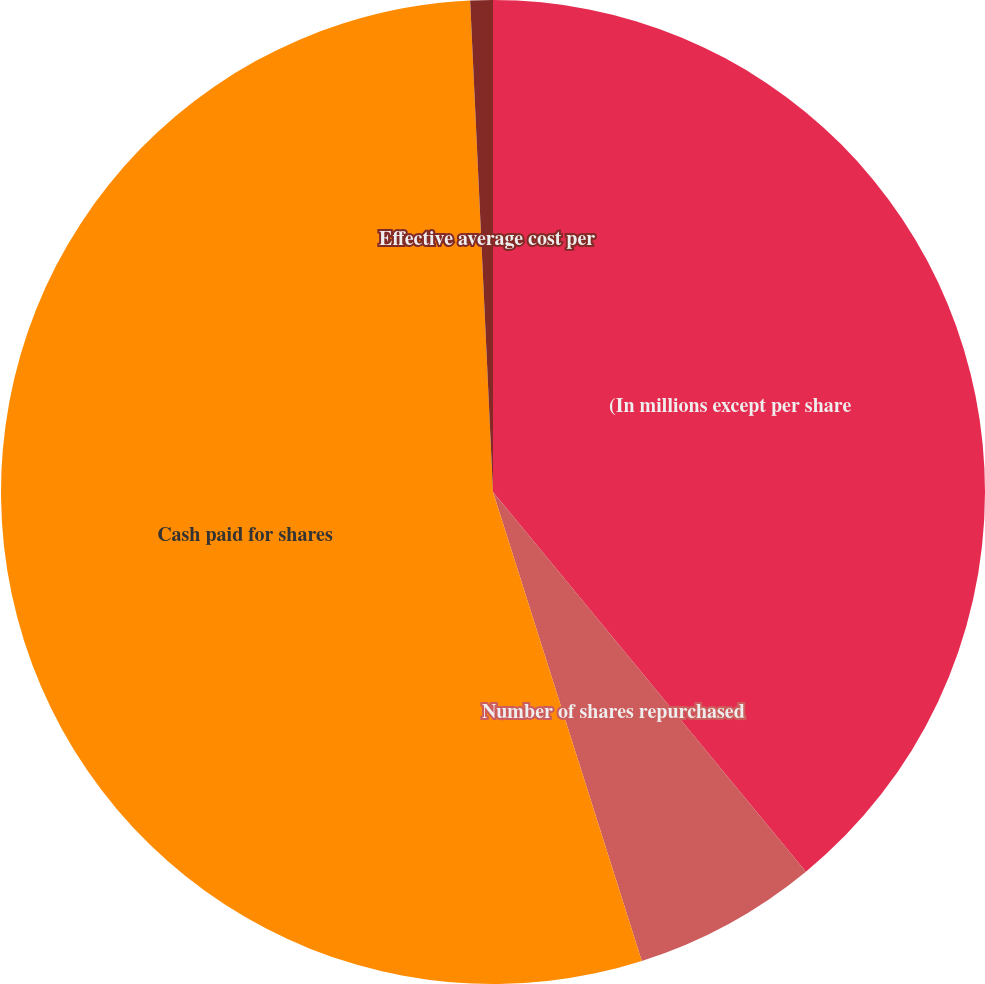Convert chart to OTSL. <chart><loc_0><loc_0><loc_500><loc_500><pie_chart><fcel>(In millions except per share<fcel>Number of shares repurchased<fcel>Cash paid for shares<fcel>Effective average cost per<nl><fcel>39.03%<fcel>6.08%<fcel>54.15%<fcel>0.74%<nl></chart> 